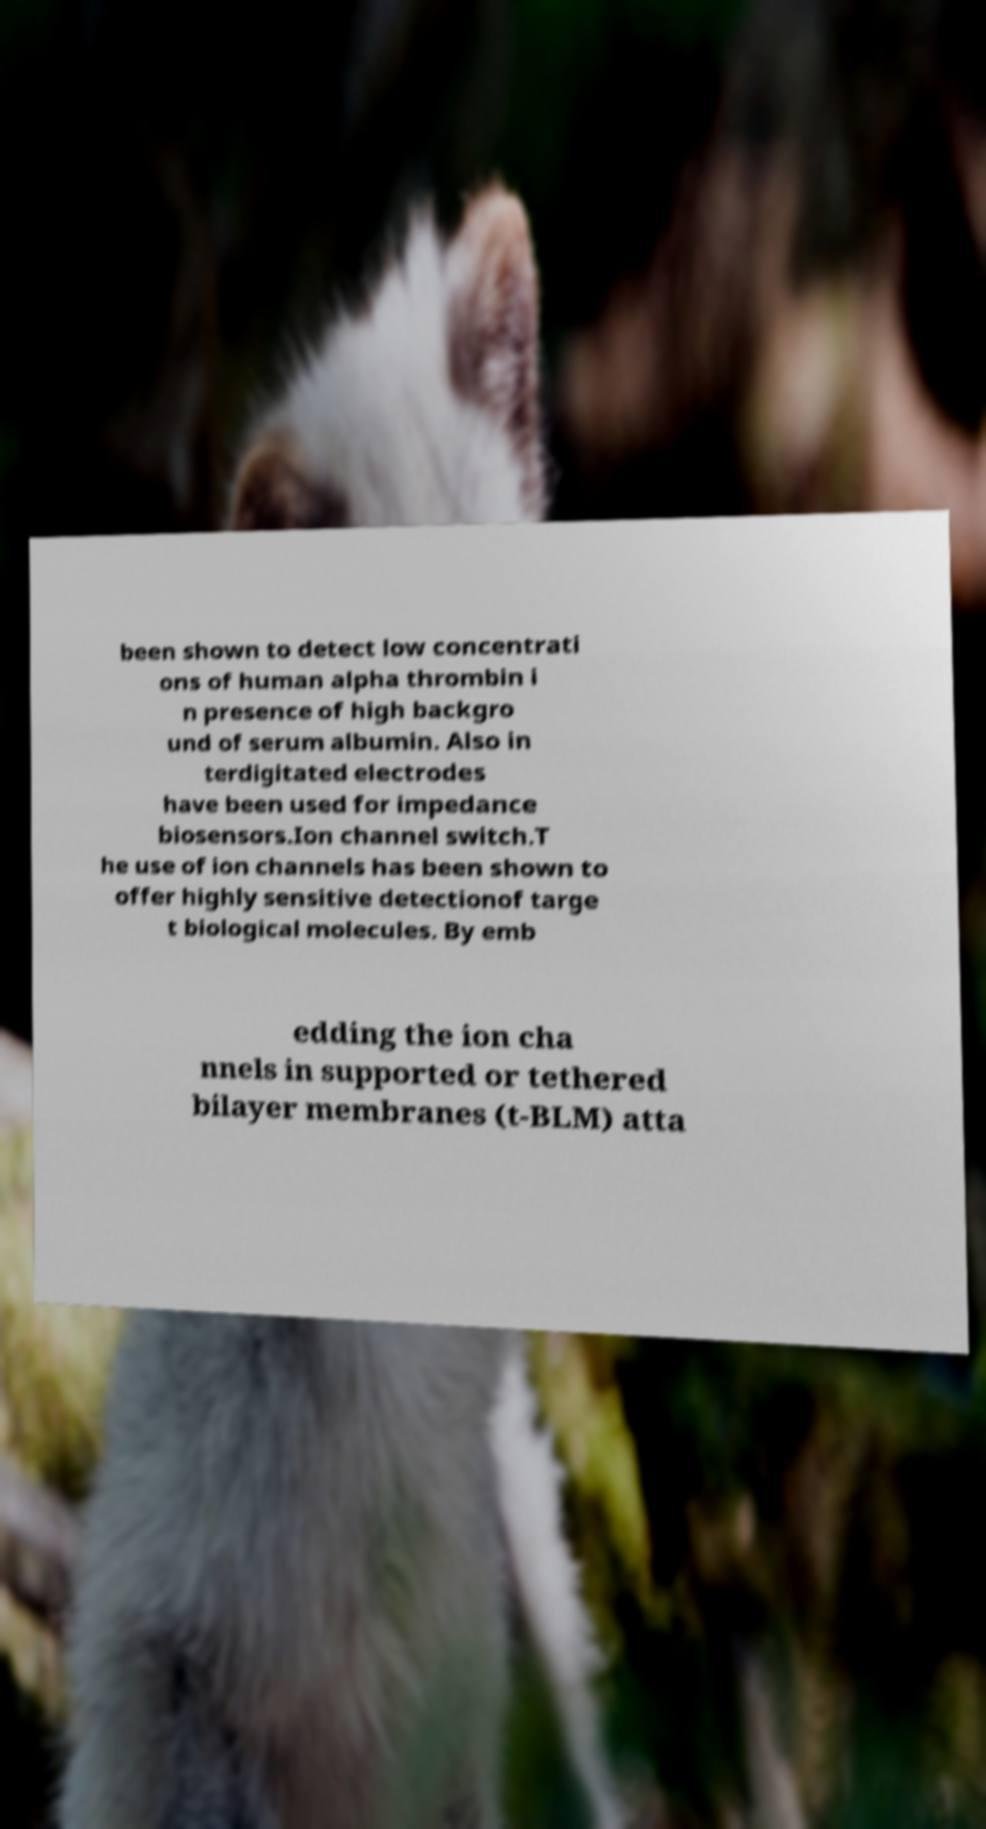Please identify and transcribe the text found in this image. been shown to detect low concentrati ons of human alpha thrombin i n presence of high backgro und of serum albumin. Also in terdigitated electrodes have been used for impedance biosensors.Ion channel switch.T he use of ion channels has been shown to offer highly sensitive detectionof targe t biological molecules. By emb edding the ion cha nnels in supported or tethered bilayer membranes (t-BLM) atta 